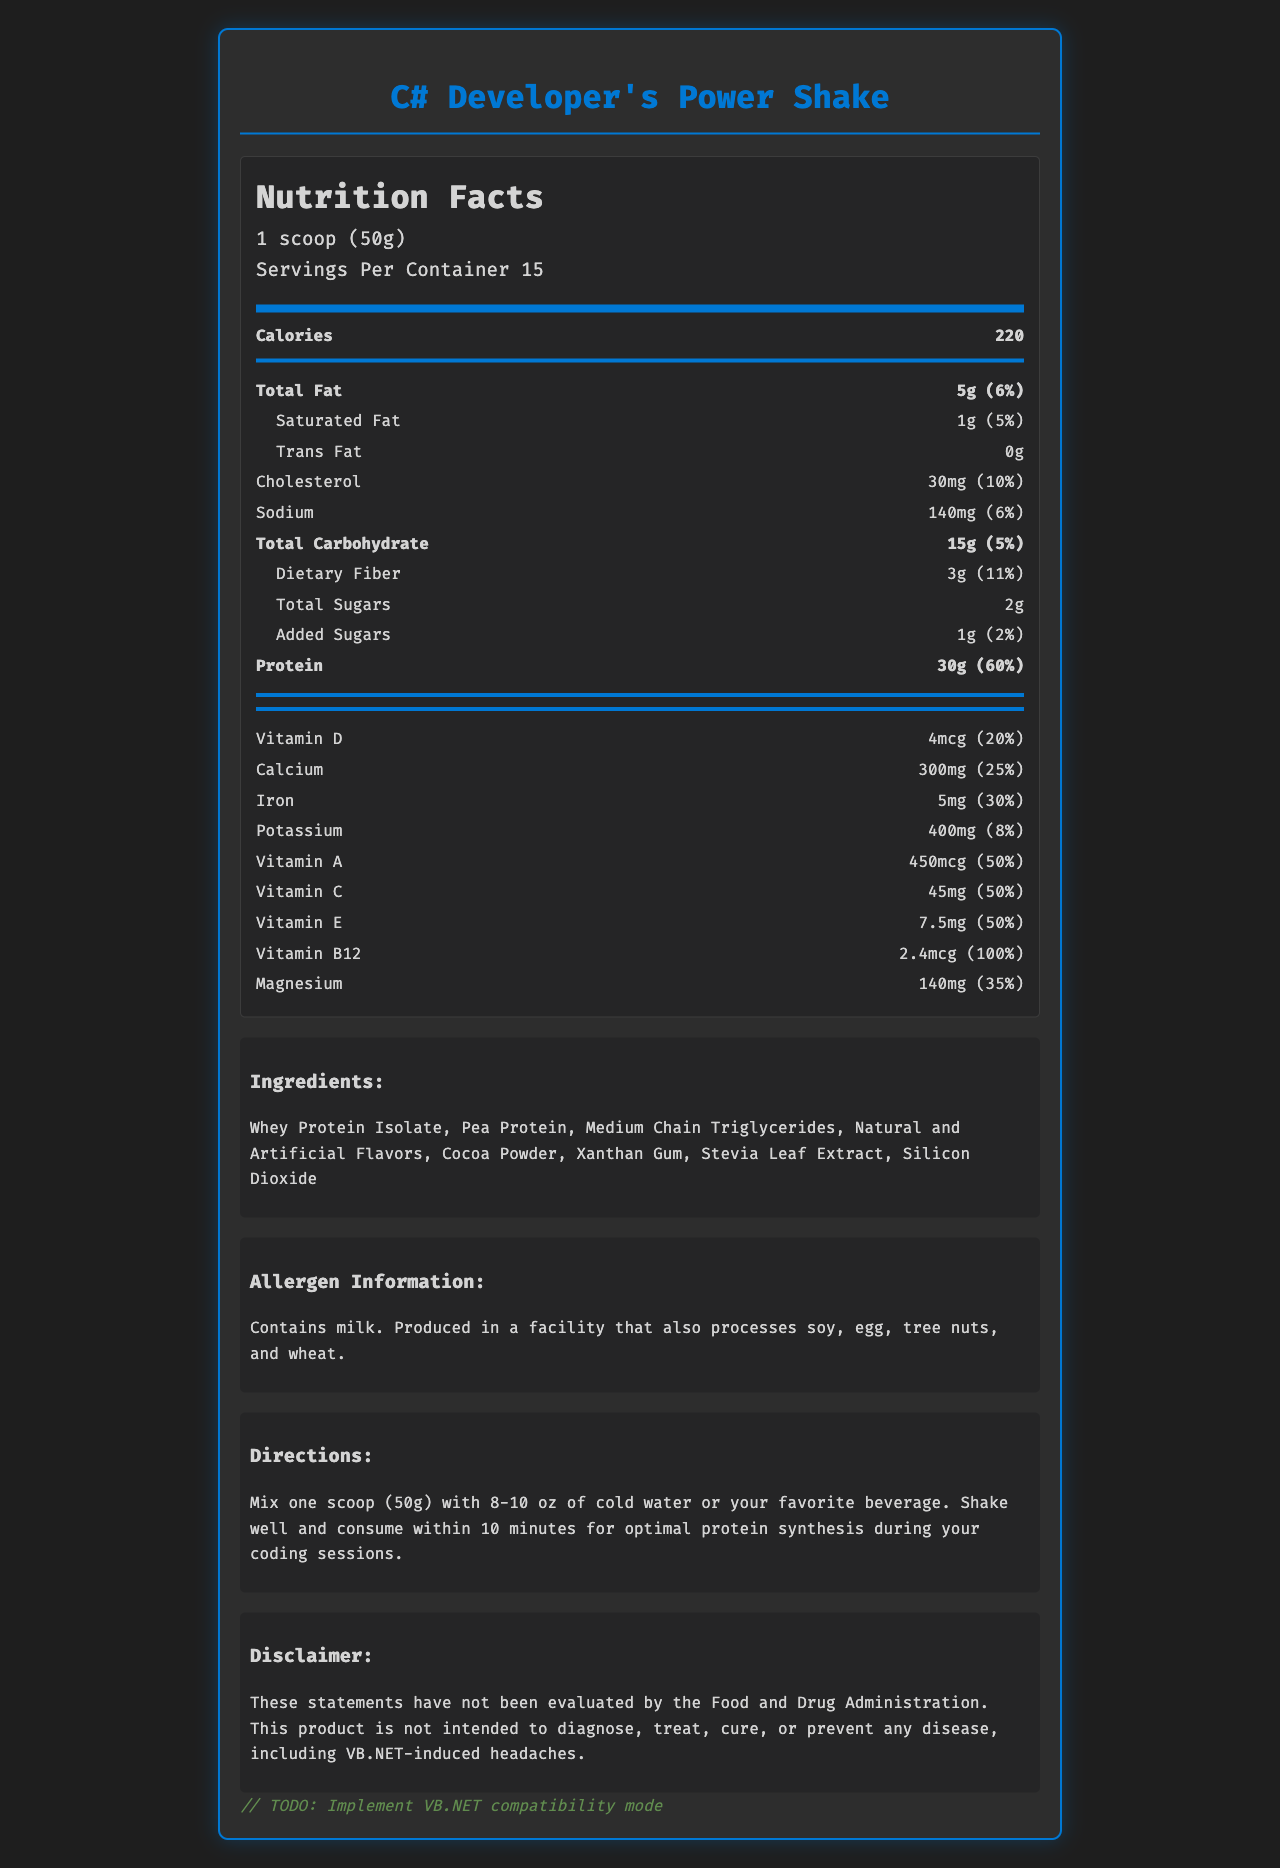what is the serving size of the product? The serving size is clearly stated at the top of the Nutrition Facts label: "1 scoop (50g)".
Answer: 1 scoop (50g) how many calories are there per serving? The number of calories per serving is shown prominently in the Nutrition Facts: "Calories 220".
Answer: 220 what are the main ingredients of the product? The ingredients are listed in the "Ingredients" section: "Whey Protein Isolate, Pea Protein, Medium Chain Triglycerides, Natural and Artificial Flavors, Cocoa Powder, Xanthan Gum, Stevia Leaf Extract, Silicon Dioxide".
Answer: Whey Protein Isolate, Pea Protein, Medium Chain Triglycerides, Natural and Artificial Flavors, Cocoa Powder, Xanthan Gum, Stevia Leaf Extract, Silicon Dioxide what is the daily value percentage of protein per serving? Under the macronutrients section for protein, it states: "Protein 30g (60%)".
Answer: 60% what is the total dietary fiber content and its daily value percentage? In the macronutrient section, it shows "Dietary Fiber 3g (11%)".
Answer: 3g, 11% how many servings are there per container? A. 10 B. 15 C. 20 D. 25 The serving information specifies: "Servings Per Container 15".
Answer: B which vitamin is present in the highest daily value percentage? A. Vitamin C B. Vitamin A C. Vitamin D D. Vitamin B12 Vitamin B12 has a daily value of 100%, which is higher than any other vitamin listed.
Answer: D is the product suitable for someone with a milk allergy? The allergen information clearly states: "Contains milk."
Answer: No does the product have trans fat? The Nutrition Facts label lists "Trans Fat 0g".
Answer: No which company manufactures the product? The manufacturer's name appears as "CodeFuel Nutrition, Inc." in the "Manufacturer Info" section.
Answer: CodeFuel Nutrition, Inc. summarize the main purpose of the document. The document is a detailed Nutrition Facts label for a high-protein meal replacement shake tailored for C# developers. It includes all necessary dietary information, instructions for use, and disclaimers about the product.
Answer: The document provides the nutrition facts, ingredients, allergen information, directions for use, storage instructions, and manufacturer details for "C# Developer's Power Shake". It highlights the macronutrient content, including the high protein content and various vitamins and minerals, along with daily value percentages. where is the "best before" date mentioned? The document does not provide any information about the "best before" date.
Answer: Not enough information what percentage of daily value for calcium does one serving provide? The vitamins and minerals section specifies "Calcium 300mg (25%)".
Answer: 25% 